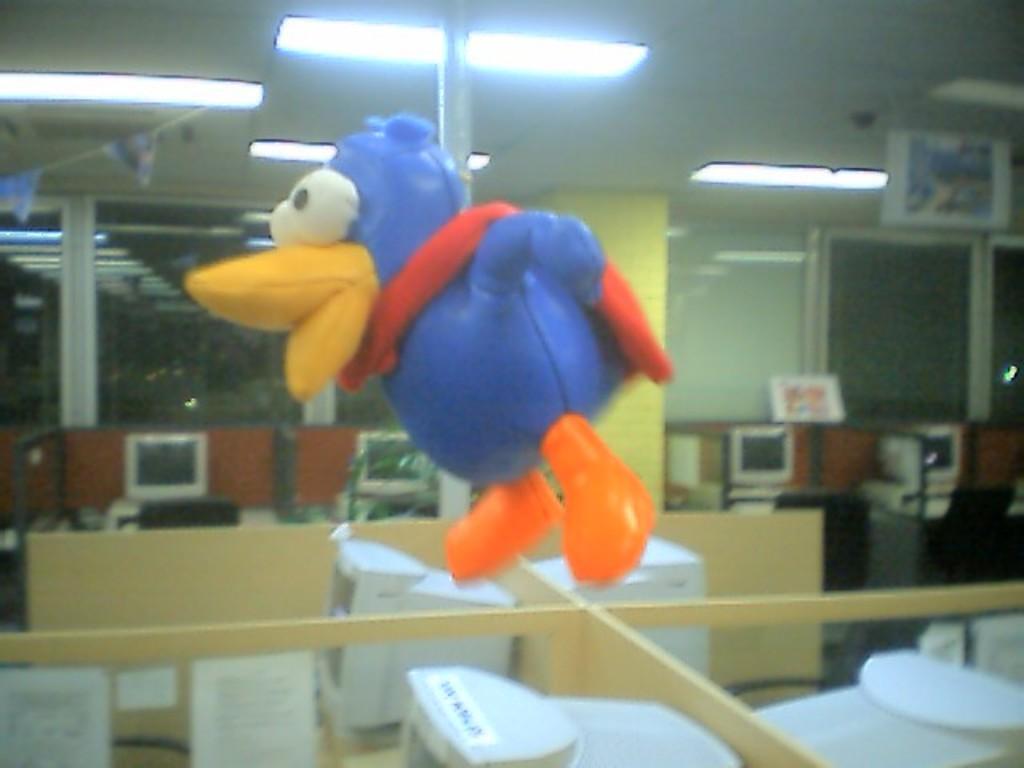Please provide a concise description of this image. In this image we can see inflatable toy, computers, lights and pillars. 